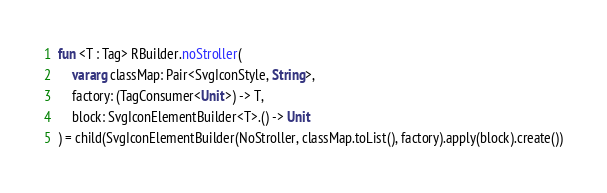<code> <loc_0><loc_0><loc_500><loc_500><_Kotlin_>
fun <T : Tag> RBuilder.noStroller(
    vararg classMap: Pair<SvgIconStyle, String>,
    factory: (TagConsumer<Unit>) -> T,
    block: SvgIconElementBuilder<T>.() -> Unit
) = child(SvgIconElementBuilder(NoStroller, classMap.toList(), factory).apply(block).create())
</code> 